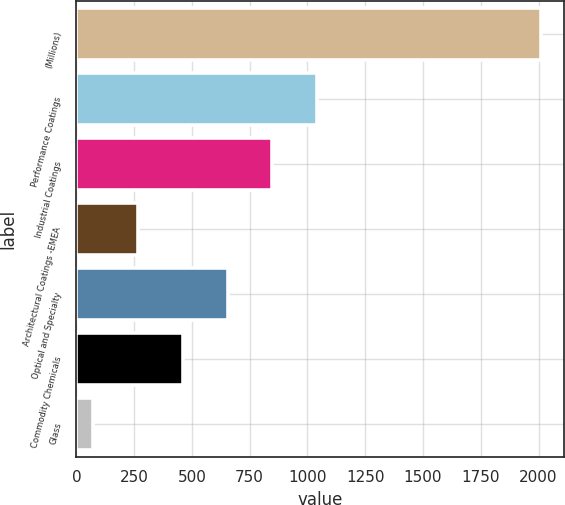<chart> <loc_0><loc_0><loc_500><loc_500><bar_chart><fcel>(Millions)<fcel>Performance Coatings<fcel>Industrial Coatings<fcel>Architectural Coatings -EMEA<fcel>Optical and Specialty<fcel>Commodity Chemicals<fcel>Glass<nl><fcel>2010<fcel>1042<fcel>848.4<fcel>267.6<fcel>654.8<fcel>461.2<fcel>74<nl></chart> 